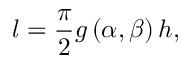Convert formula to latex. <formula><loc_0><loc_0><loc_500><loc_500>l = \frac { \pi } { 2 } g \left ( \alpha , \beta \right ) h ,</formula> 